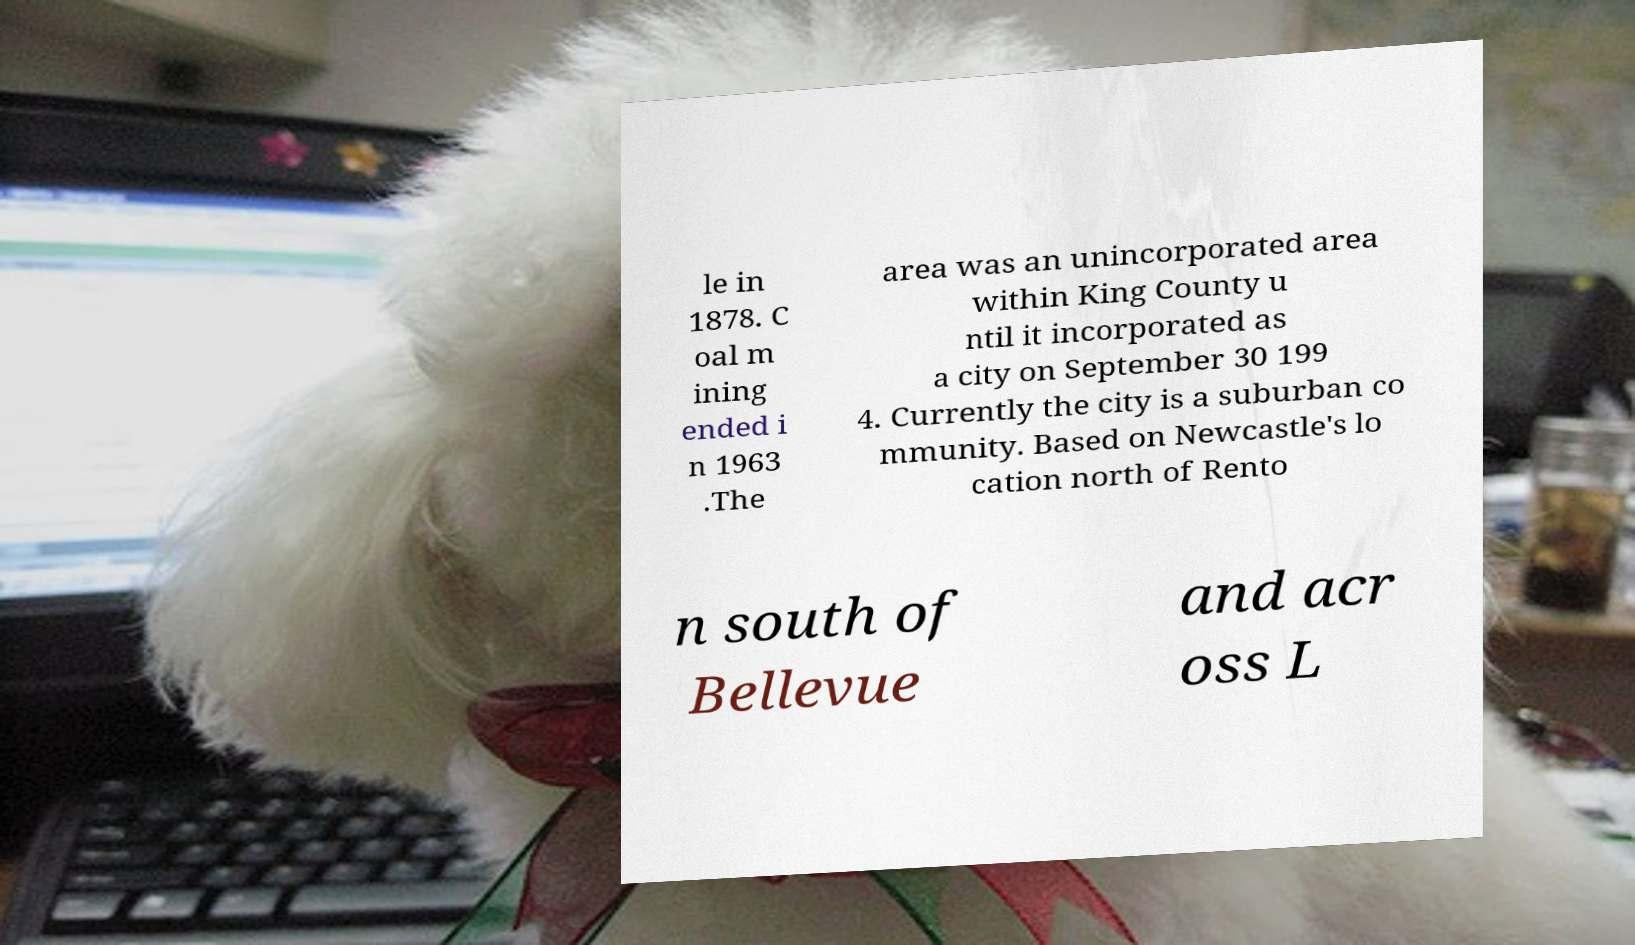For documentation purposes, I need the text within this image transcribed. Could you provide that? le in 1878. C oal m ining ended i n 1963 .The area was an unincorporated area within King County u ntil it incorporated as a city on September 30 199 4. Currently the city is a suburban co mmunity. Based on Newcastle's lo cation north of Rento n south of Bellevue and acr oss L 